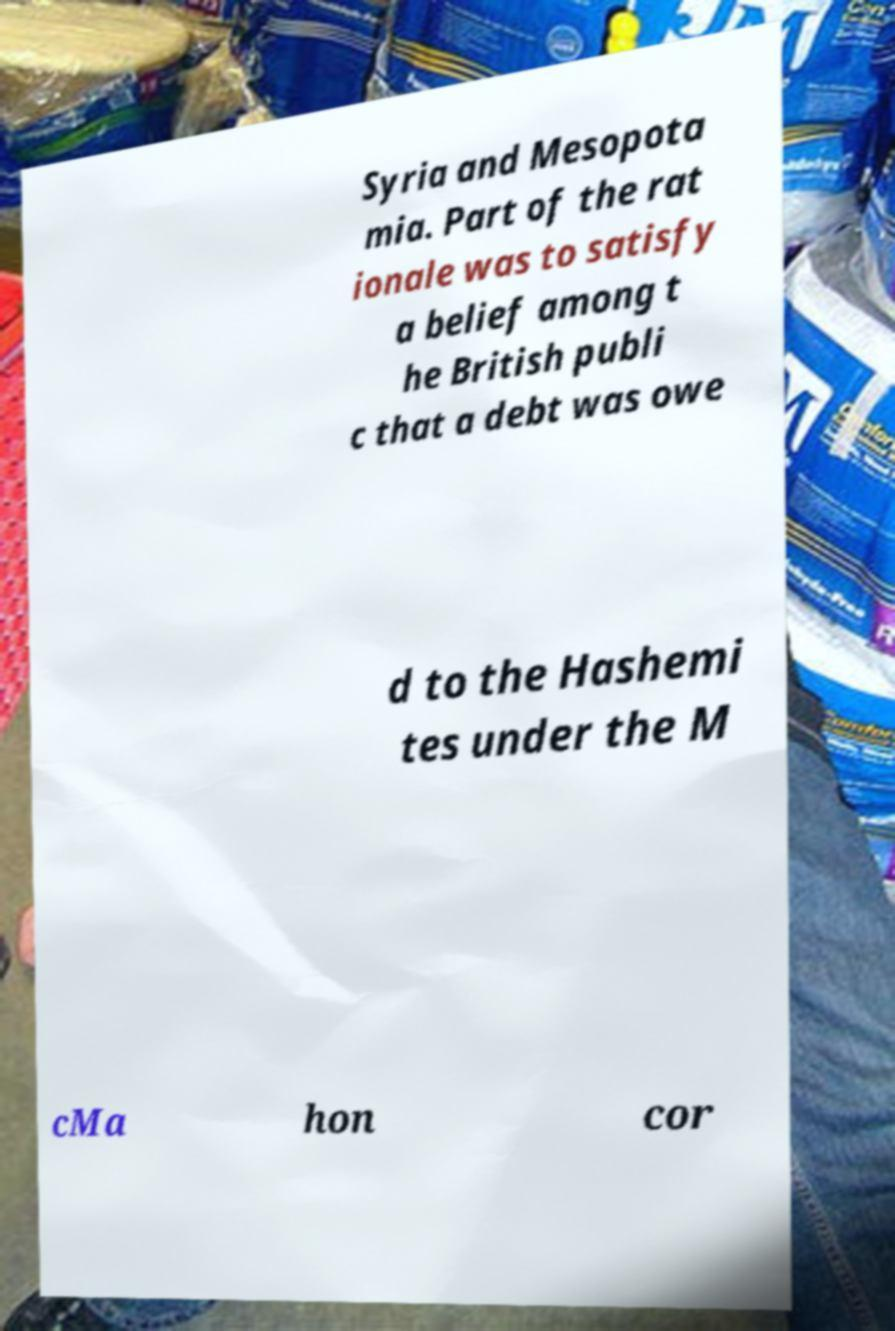I need the written content from this picture converted into text. Can you do that? Syria and Mesopota mia. Part of the rat ionale was to satisfy a belief among t he British publi c that a debt was owe d to the Hashemi tes under the M cMa hon cor 